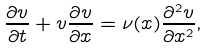<formula> <loc_0><loc_0><loc_500><loc_500>\frac { \partial v } { \partial t } + v \frac { \partial v } { \partial x } = \nu ( x ) \frac { \partial ^ { 2 } v } { \partial x ^ { 2 } } ,</formula> 